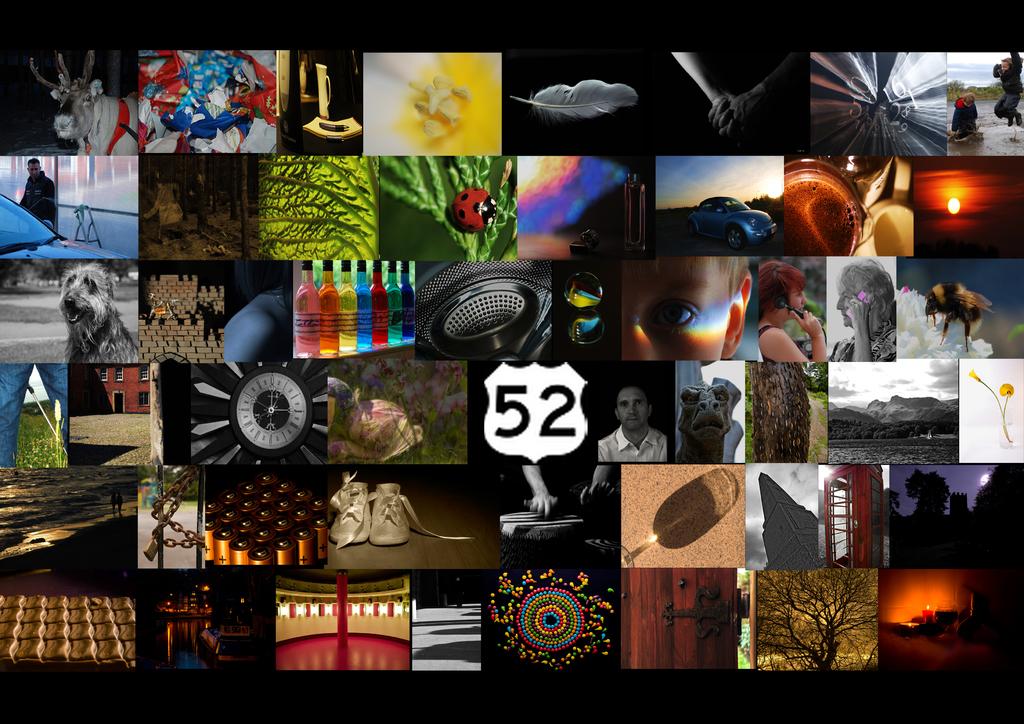What is the number on the sign?
Offer a terse response. 52. 